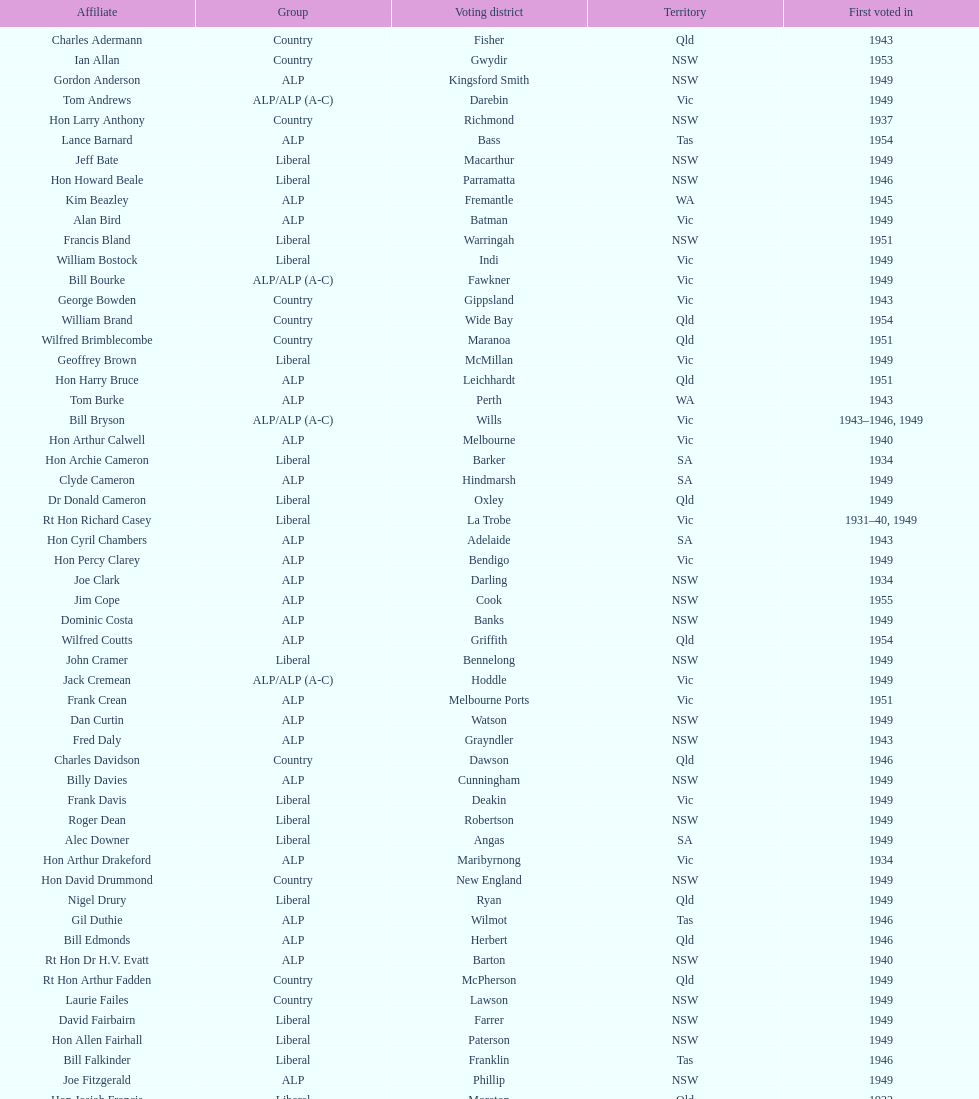Previous to tom andrews who was elected? Gordon Anderson. 